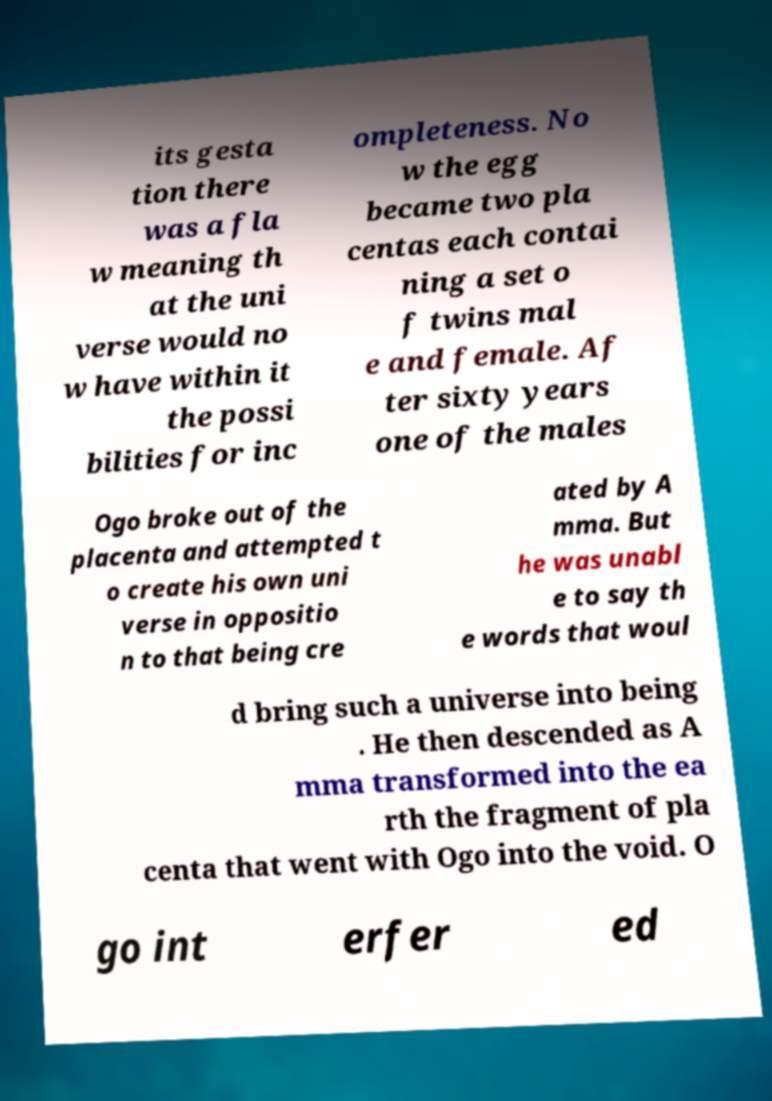Please read and relay the text visible in this image. What does it say? its gesta tion there was a fla w meaning th at the uni verse would no w have within it the possi bilities for inc ompleteness. No w the egg became two pla centas each contai ning a set o f twins mal e and female. Af ter sixty years one of the males Ogo broke out of the placenta and attempted t o create his own uni verse in oppositio n to that being cre ated by A mma. But he was unabl e to say th e words that woul d bring such a universe into being . He then descended as A mma transformed into the ea rth the fragment of pla centa that went with Ogo into the void. O go int erfer ed 